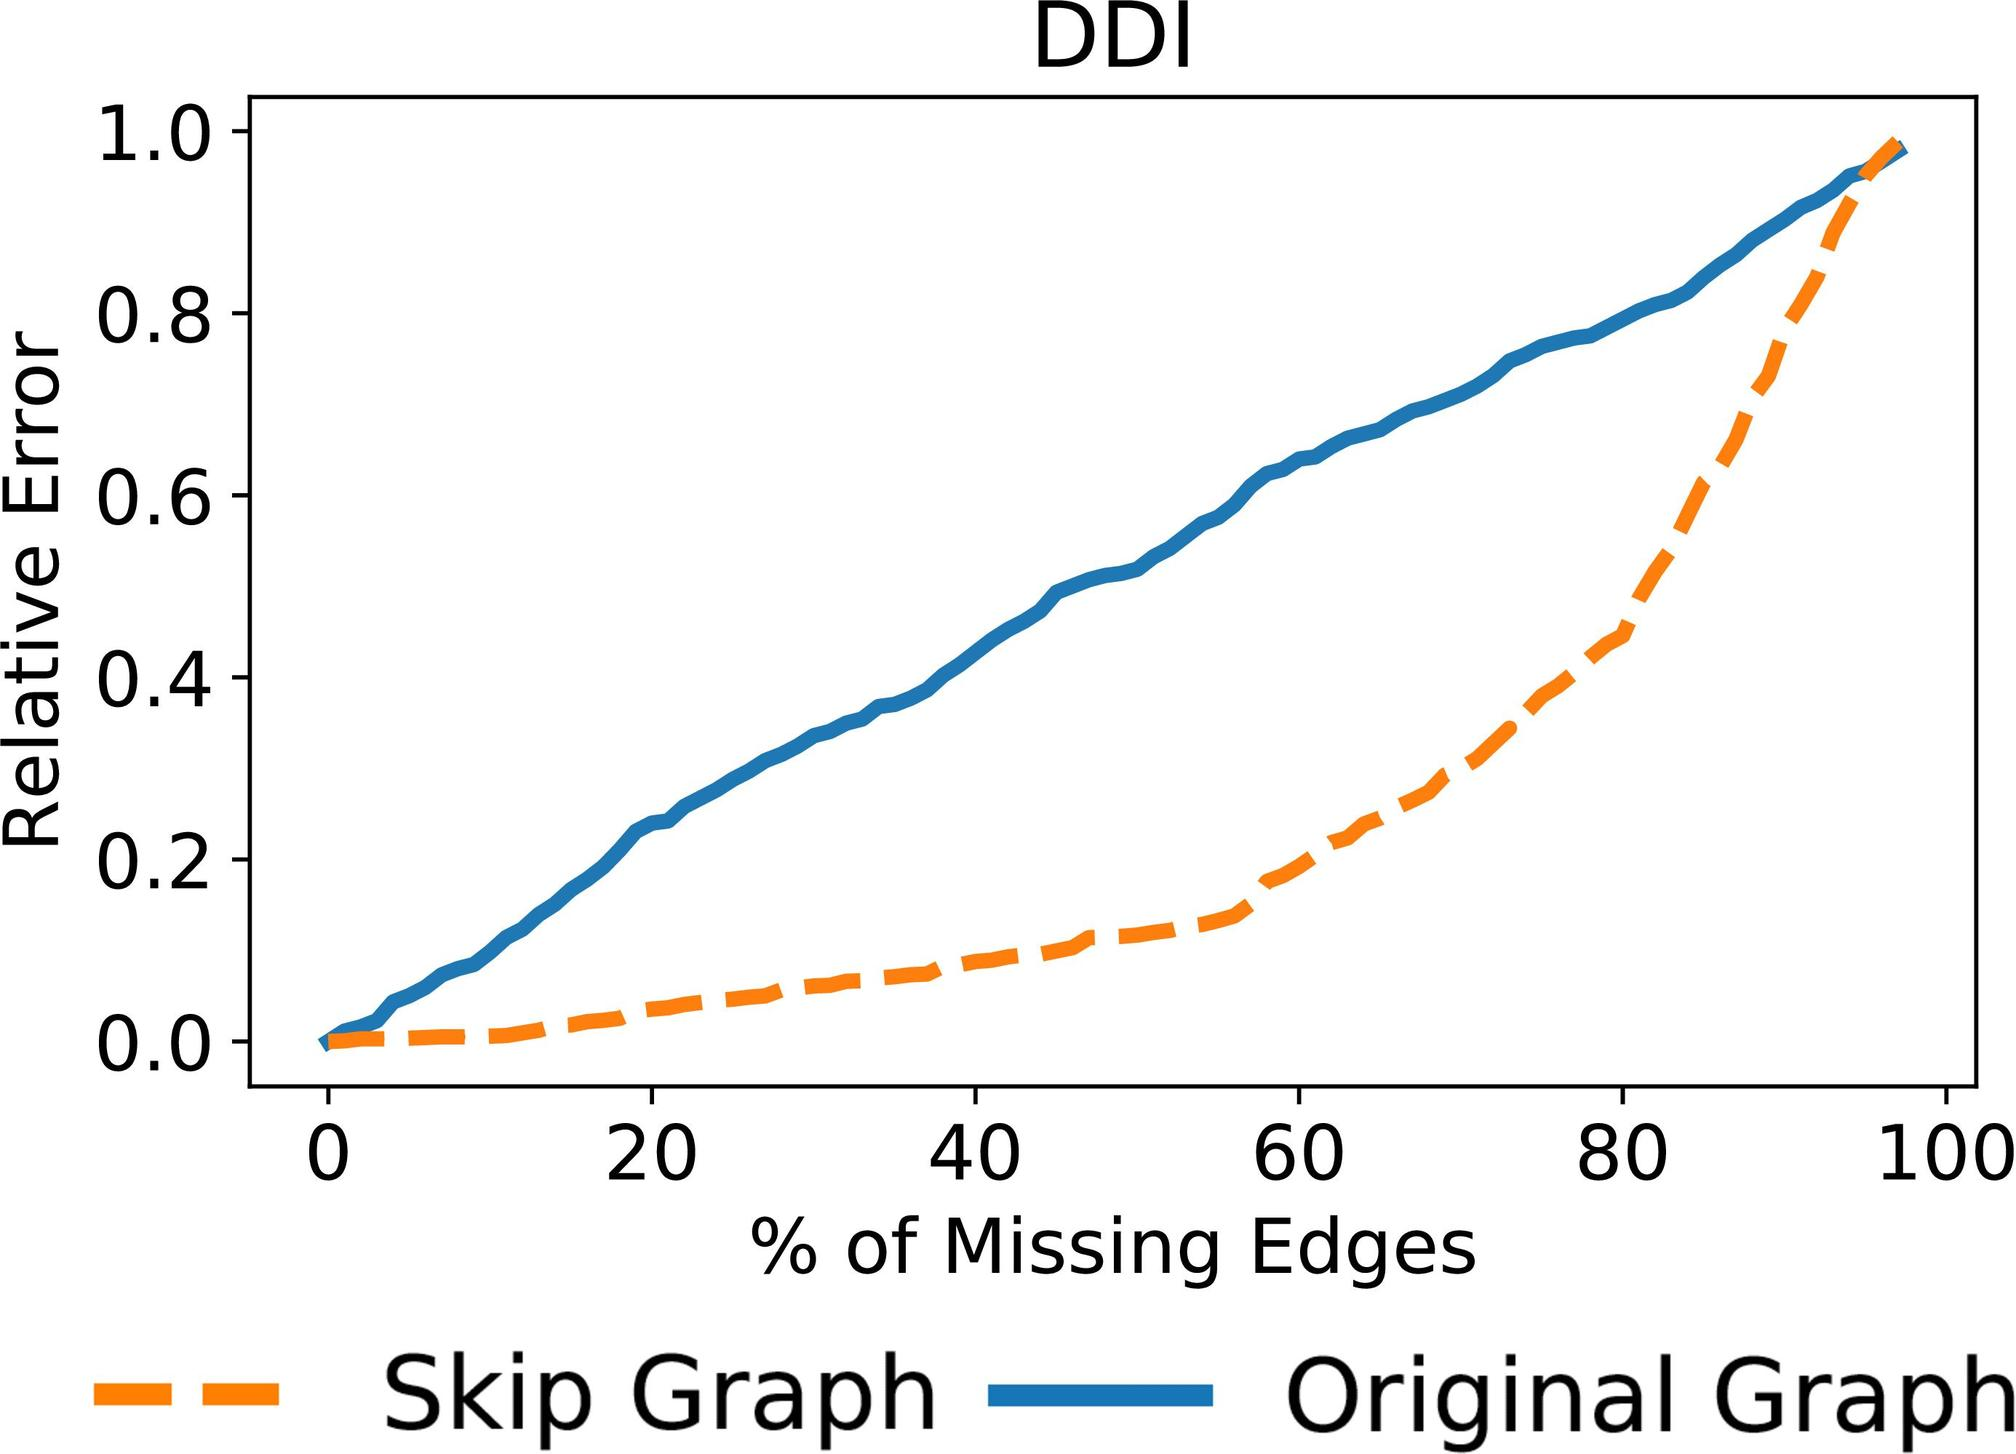Can you explain the significance of the x-axis labeled 'Percentage of Missing Edges' in understanding graph resilience? The x-axis of the graph, labeled 'Percentage of Missing Edges,' is crucial for assessing graph resilience as it quantifies the extent to which the graph's structure is compromised. By analyzing how the relative error changes with increasing missing edges, one can infer the robustness of a graph structure. A steeper increase in error may indicate a higher sensitivity to disruptions in connectivity, which is critical for applications requiring high reliability and fault tolerance. 